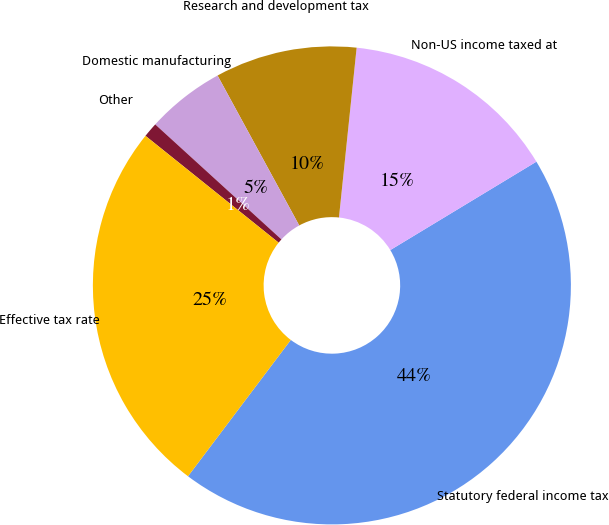Convert chart to OTSL. <chart><loc_0><loc_0><loc_500><loc_500><pie_chart><fcel>Statutory federal income tax<fcel>Non-US income taxed at<fcel>Research and development tax<fcel>Domestic manufacturing<fcel>Other<fcel>Effective tax rate<nl><fcel>43.94%<fcel>14.69%<fcel>9.59%<fcel>5.3%<fcel>1.0%<fcel>25.48%<nl></chart> 